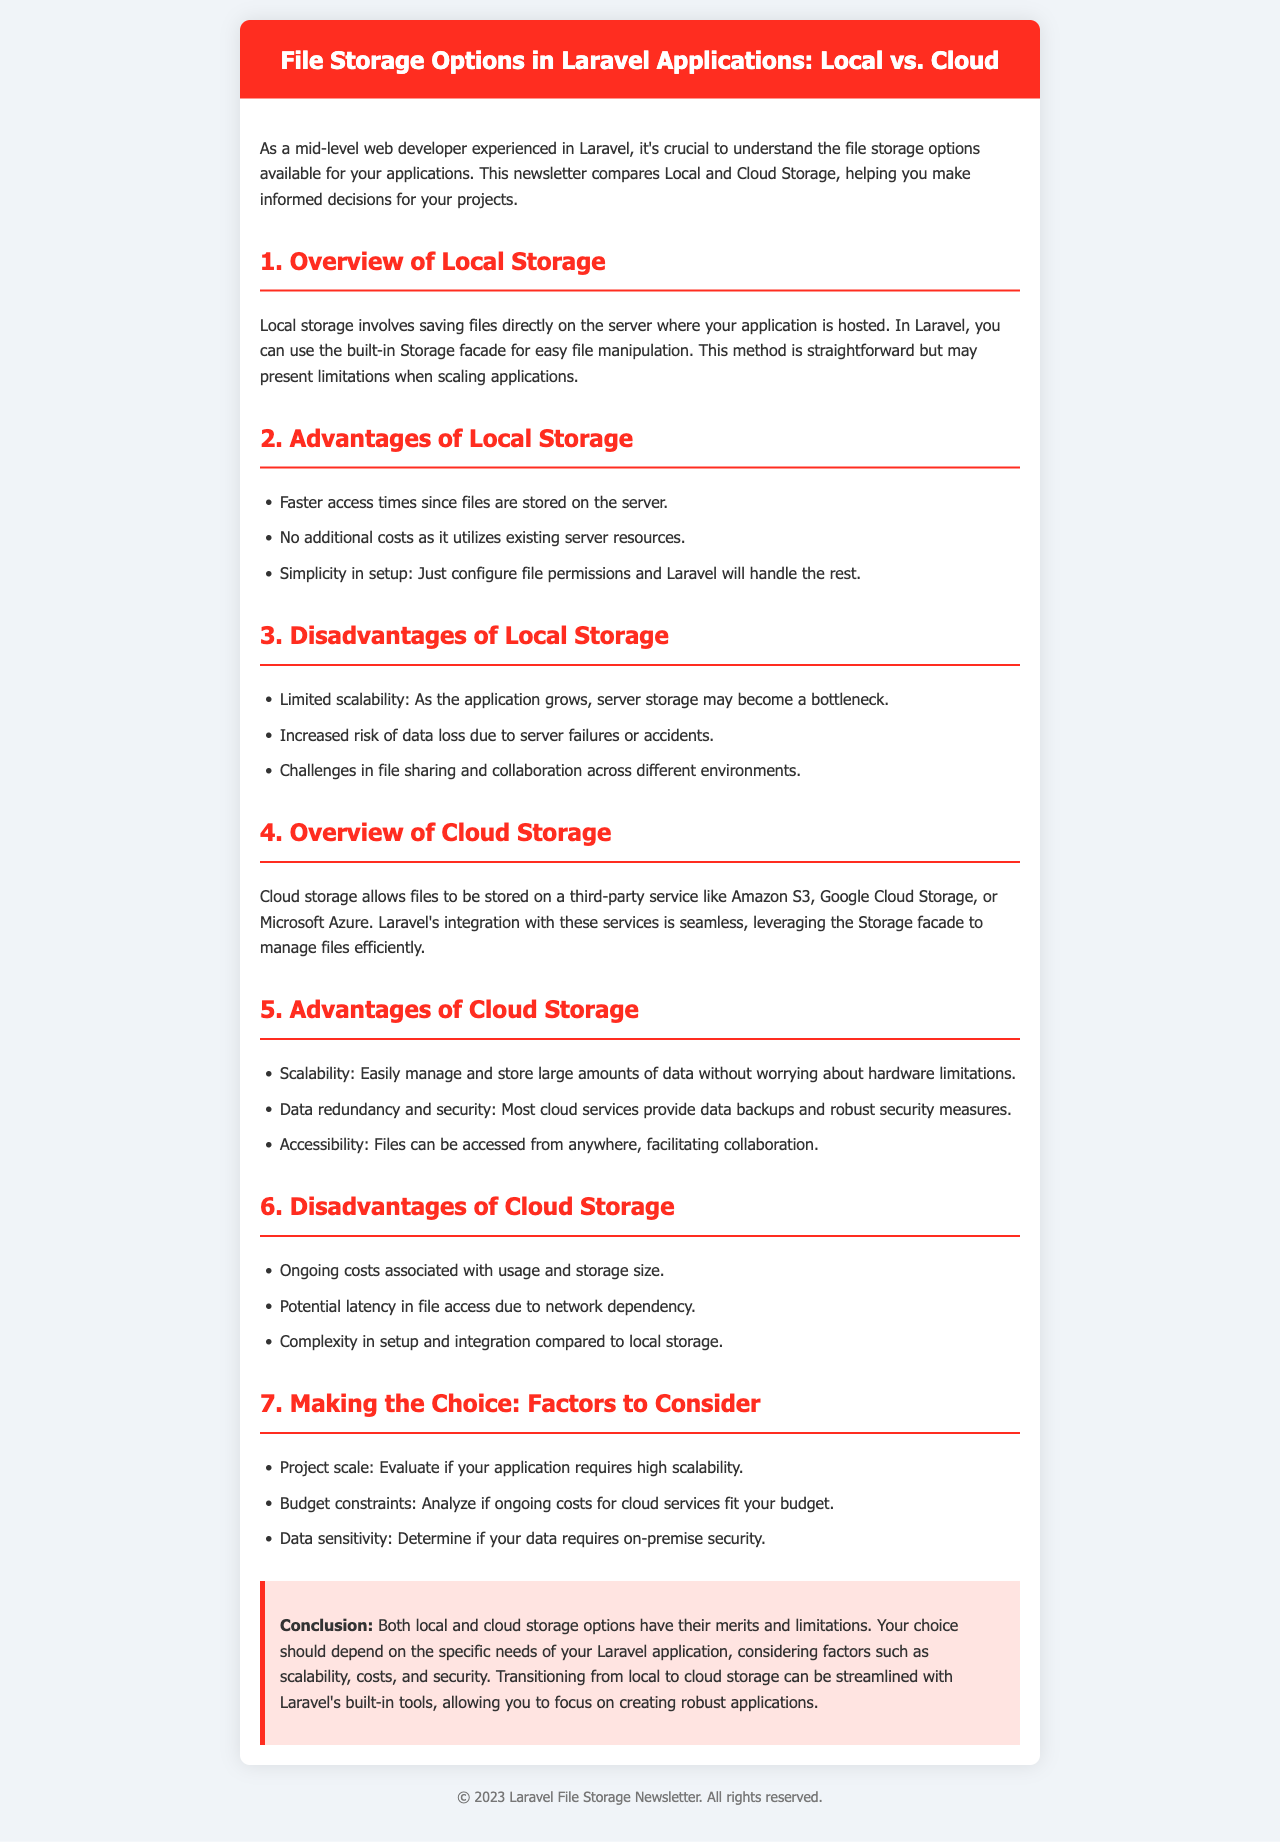What is the title of the newsletter? The title is stated in the header section of the document.
Answer: File Storage Options in Laravel Applications: Local vs. Cloud What are the two main types of storage compared? The document clearly identifies the two types of storage being compared.
Answer: Local and Cloud Storage What is one advantage of using local storage? The document lists advantages of local storage under a specific section.
Answer: Faster access times What is one disadvantage of using cloud storage? The document outlines disadvantages of cloud storage, providing specific details.
Answer: Ongoing costs What is a factor to consider when choosing storage? The section on making choices lists various factors to consider for storage options.
Answer: Project scale What color is used for the header background? The document describes the visual design elements including colors.
Answer: Red What type of document is this? The format and presentation of the content suggest a specific type of document.
Answer: Newsletter How many advantages of local storage are listed? The document states the number of advantages listed in the respective section.
Answer: Three What background color is used for the conclusion section? The document details specific style attributes for the conclusion section.
Answer: Light pink 